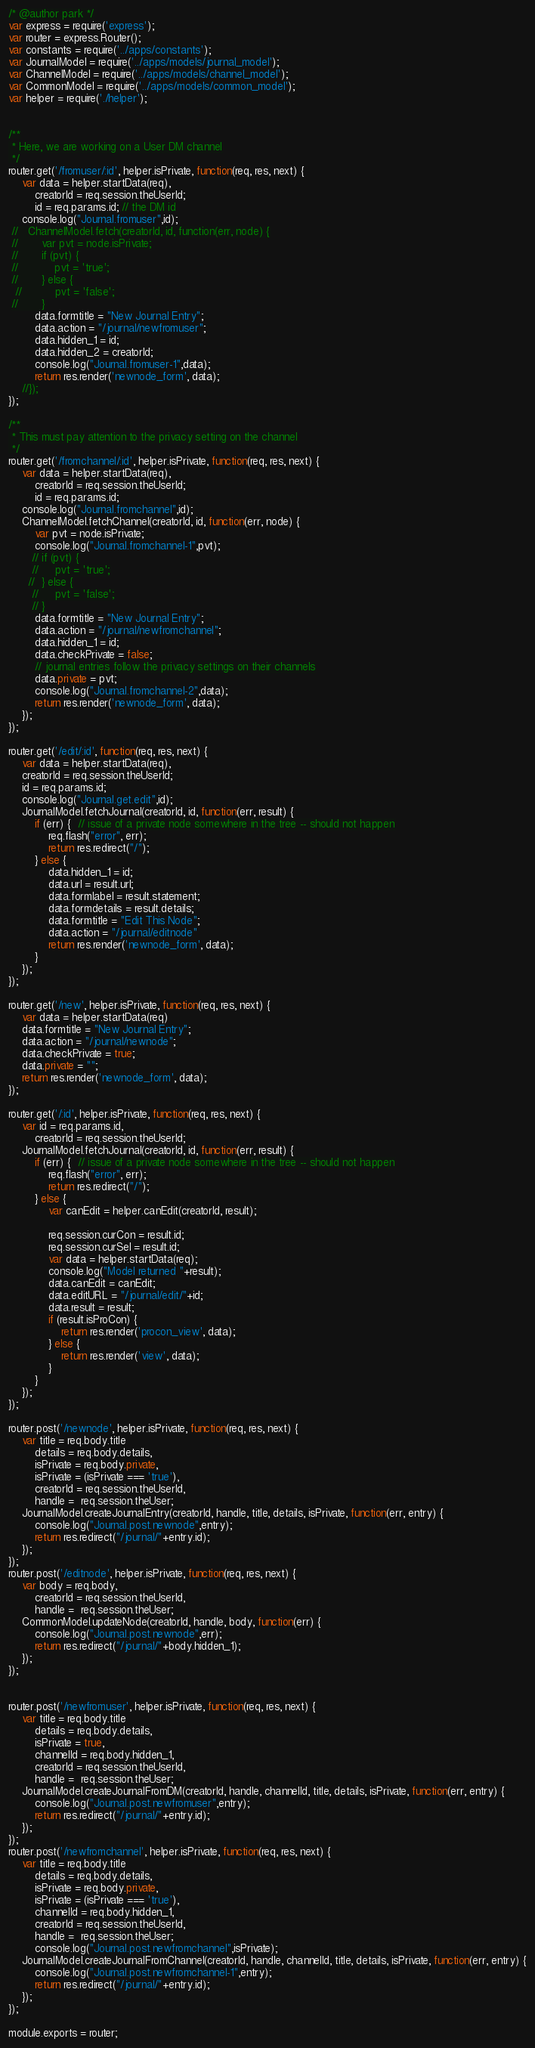Convert code to text. <code><loc_0><loc_0><loc_500><loc_500><_JavaScript_>/* @author park */
var express = require('express');
var router = express.Router();
var constants = require('../apps/constants');
var JournalModel = require('../apps/models/journal_model');
var ChannelModel = require('../apps/models/channel_model');
var CommonModel = require('../apps/models/common_model');
var helper = require('./helper');


/**
 * Here, we are working on a User DM channel
 */
router.get('/fromuser/:id', helper.isPrivate, function(req, res, next) {
    var data = helper.startData(req),
        creatorId = req.session.theUserId;
        id = req.params.id; // the DM id
    console.log("Journal.fromuser",id);
 //   ChannelModel.fetch(creatorId, id, function(err, node) {
 //       var pvt = node.isPrivate;
 //       if (pvt) {
 //           pvt = 'true';
 //       } else {
  //          pvt = 'false';
 //       }
        data.formtitle = "New Journal Entry";
        data.action = "/journal/newfromuser";
        data.hidden_1 = id; 
        data.hidden_2 = creatorId;
        console.log("Journal.fromuser-1",data);
        return res.render('newnode_form', data);
    //});
});

/**
 * This must pay attention to the privacy setting on the channel
 */
router.get('/fromchannel/:id', helper.isPrivate, function(req, res, next) {
    var data = helper.startData(req),
        creatorId = req.session.theUserId;
        id = req.params.id;
    console.log("Journal.fromchannel",id);
    ChannelModel.fetchChannel(creatorId, id, function(err, node) {
        var pvt = node.isPrivate;
        console.log("Journal.fromchannel-1",pvt);
       // if (pvt) {
       //     pvt = 'true';
      //  } else {
       //     pvt = 'false';
       // }
        data.formtitle = "New Journal Entry";
        data.action = "/journal/newfromchannel";
        data.hidden_1 = id;
        data.checkPrivate = false;
        // journal entries follow the privacy settings on their channels
        data.private = pvt;
        console.log("Journal.fromchannel-2",data);
        return res.render('newnode_form', data);
    });
});

router.get('/edit/:id', function(req, res, next) {
    var data = helper.startData(req),
    creatorId = req.session.theUserId;
    id = req.params.id;
    console.log("Journal.get.edit",id);
    JournalModel.fetchJournal(creatorId, id, function(err, result) {
        if (err) {  // issue of a private node somewhere in the tree -- should not happen
            req.flash("error", err);
            return res.redirect("/");
        } else {
            data.hidden_1 = id;
            data.url = result.url;
            data.formlabel = result.statement;
            data.formdetails = result.details;
            data.formtitle = "Edit This Node";
            data.action = "/journal/editnode"
            return res.render('newnode_form', data);
        }
    });
});

router.get('/new', helper.isPrivate, function(req, res, next) {
    var data = helper.startData(req)
    data.formtitle = "New Journal Entry";
    data.action = "/journal/newnode";
    data.checkPrivate = true;
    data.private = "";
    return res.render('newnode_form', data);
});

router.get('/:id', helper.isPrivate, function(req, res, next) {
    var id = req.params.id,
        creatorId = req.session.theUserId;
    JournalModel.fetchJournal(creatorId, id, function(err, result) {
        if (err) {  // issue of a private node somewhere in the tree -- should not happen
            req.flash("error", err);
            return res.redirect("/");
        } else {
            var canEdit = helper.canEdit(creatorId, result);
 
            req.session.curCon = result.id;
            req.session.curSel = result.id;
            var data = helper.startData(req);
            console.log("Model returned "+result);
            data.canEdit = canEdit;
            data.editURL = "/journal/edit/"+id;
            data.result = result;
            if (result.isProCon) {
                return res.render('procon_view', data);
            } else {
                return res.render('view', data);
            }
        }
    });
});

router.post('/newnode', helper.isPrivate, function(req, res, next) {
    var title = req.body.title
        details = req.body.details,
        isPrivate = req.body.private,
        isPrivate = (isPrivate === 'true'),
        creatorId = req.session.theUserId,
        handle =  req.session.theUser;
    JournalModel.createJournalEntry(creatorId, handle, title, details, isPrivate, function(err, entry) {
        console.log("Journal.post.newnode",entry);
        return res.redirect("/journal/"+entry.id);
    });
});
router.post('/editnode', helper.isPrivate, function(req, res, next) {
    var body = req.body,
        creatorId = req.session.theUserId,
        handle =  req.session.theUser;
    CommonModel.updateNode(creatorId, handle, body, function(err) {
        console.log("Journal.post.newnode",err);
        return res.redirect("/journal/"+body.hidden_1);
    });
});


router.post('/newfromuser', helper.isPrivate, function(req, res, next) {
    var title = req.body.title
        details = req.body.details,
        isPrivate = true,
        channelId = req.body.hidden_1,
        creatorId = req.session.theUserId,
        handle =  req.session.theUser;
    JournalModel.createJournalFromDM(creatorId, handle, channelId, title, details, isPrivate, function(err, entry) {
        console.log("Journal.post.newfromuser",entry);
        return res.redirect("/journal/"+entry.id);
    });
});
router.post('/newfromchannel', helper.isPrivate, function(req, res, next) {
    var title = req.body.title
        details = req.body.details,
        isPrivate = req.body.private,
        isPrivate = (isPrivate === 'true'),
        channelId = req.body.hidden_1,
        creatorId = req.session.theUserId,
        handle =  req.session.theUser;
        console.log("Journal.post.newfromchannel",isPrivate);
    JournalModel.createJournalFromChannel(creatorId, handle, channelId, title, details, isPrivate, function(err, entry) {
        console.log("Journal.post.newfromchannel-1",entry);
        return res.redirect("/journal/"+entry.id);
    });
});

module.exports = router;</code> 